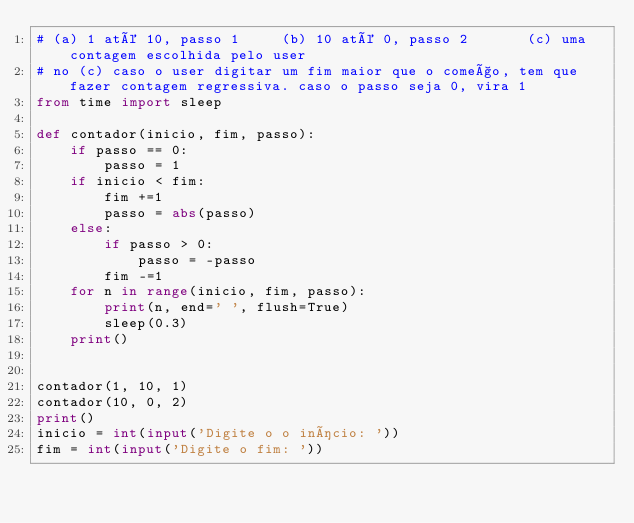Convert code to text. <code><loc_0><loc_0><loc_500><loc_500><_Python_># (a) 1 até 10, passo 1     (b) 10 até 0, passo 2       (c) uma contagem escolhida pelo user 
# no (c) caso o user digitar um fim maior que o começo, tem que fazer contagem regressiva. caso o passo seja 0, vira 1
from time import sleep

def contador(inicio, fim, passo):
    if passo == 0:
        passo = 1
    if inicio < fim:
        fim +=1
        passo = abs(passo)
    else:
        if passo > 0:
            passo = -passo
        fim -=1
    for n in range(inicio, fim, passo):
        print(n, end=' ', flush=True)
        sleep(0.3)
    print()


contador(1, 10, 1)
contador(10, 0, 2)
print()
inicio = int(input('Digite o o início: '))
fim = int(input('Digite o fim: '))</code> 